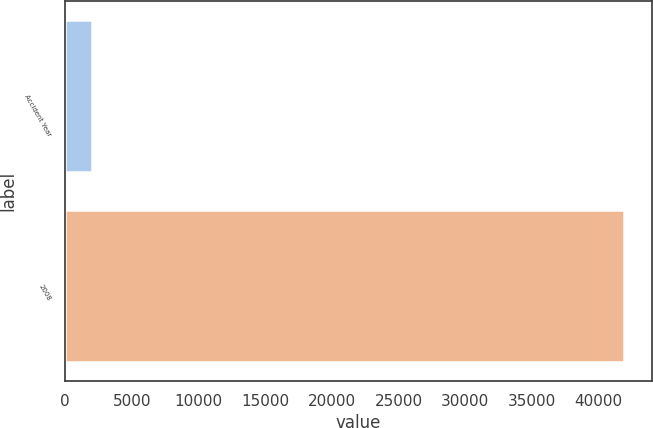Convert chart. <chart><loc_0><loc_0><loc_500><loc_500><bar_chart><fcel>Accident Year<fcel>2008<nl><fcel>2017<fcel>41921<nl></chart> 